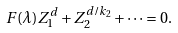Convert formula to latex. <formula><loc_0><loc_0><loc_500><loc_500>F ( \lambda ) Z _ { 1 } ^ { d } + Z _ { 2 } ^ { d / k _ { 2 } } + \cdots = 0 .</formula> 